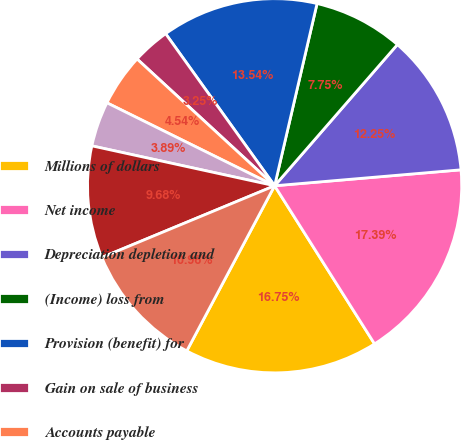Convert chart. <chart><loc_0><loc_0><loc_500><loc_500><pie_chart><fcel>Millions of dollars<fcel>Net income<fcel>Depreciation depletion and<fcel>(Income) loss from<fcel>Provision (benefit) for<fcel>Gain on sale of business<fcel>Accounts payable<fcel>Contributions to pension plans<fcel>Inventories<fcel>Receivables<nl><fcel>16.75%<fcel>17.39%<fcel>12.25%<fcel>7.75%<fcel>13.54%<fcel>3.25%<fcel>4.54%<fcel>3.89%<fcel>9.68%<fcel>10.96%<nl></chart> 